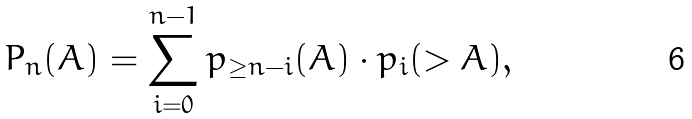<formula> <loc_0><loc_0><loc_500><loc_500>P _ { n } ( A ) = \sum _ { i = 0 } ^ { n - 1 } p _ { \geq n - i } ( A ) \cdot p _ { i } ( > A ) ,</formula> 